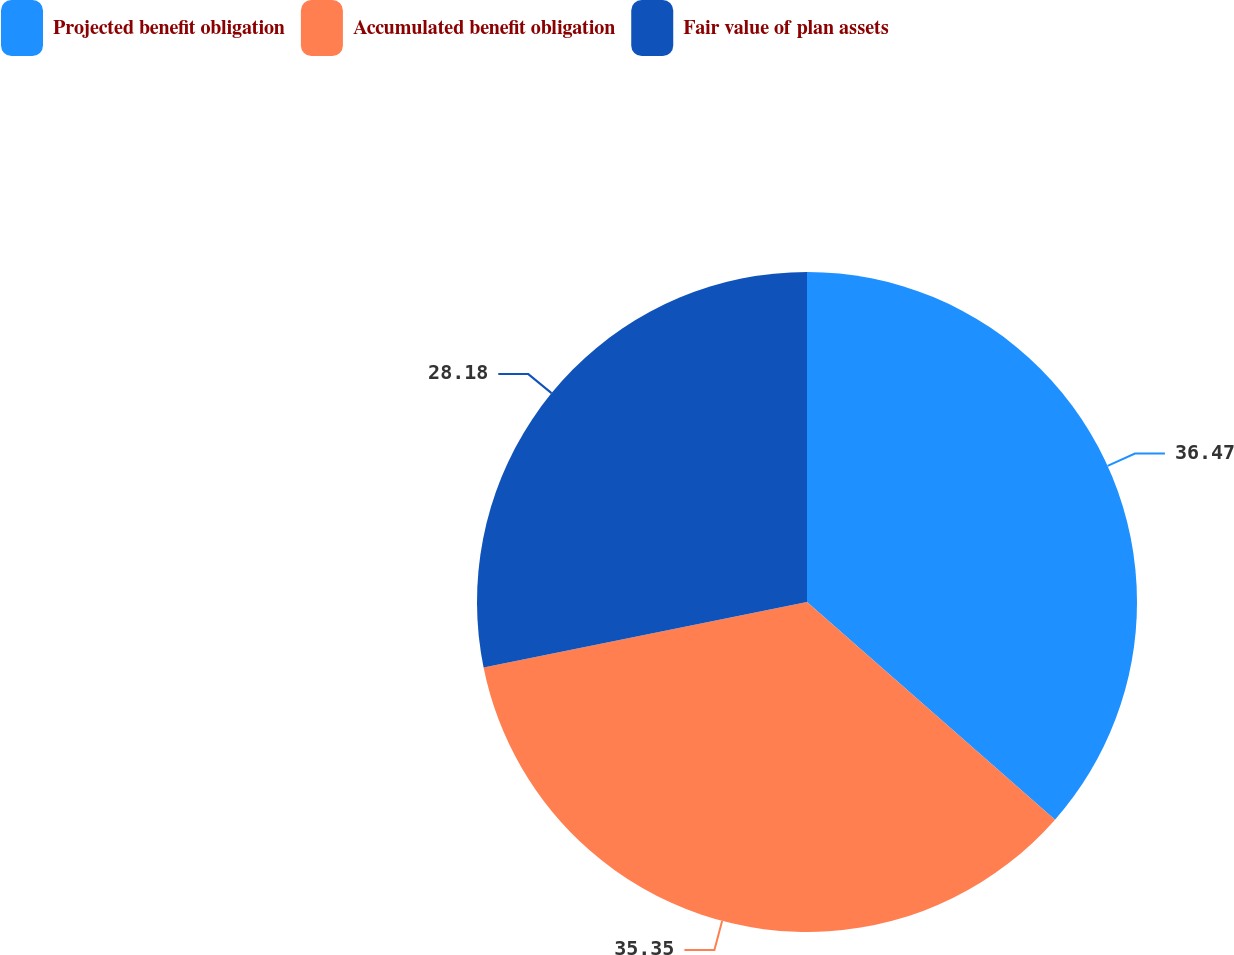<chart> <loc_0><loc_0><loc_500><loc_500><pie_chart><fcel>Projected benefit obligation<fcel>Accumulated benefit obligation<fcel>Fair value of plan assets<nl><fcel>36.46%<fcel>35.35%<fcel>28.18%<nl></chart> 